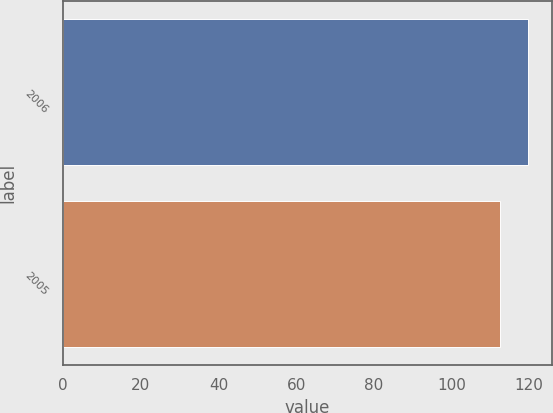Convert chart to OTSL. <chart><loc_0><loc_0><loc_500><loc_500><bar_chart><fcel>2006<fcel>2005<nl><fcel>119.8<fcel>112.4<nl></chart> 